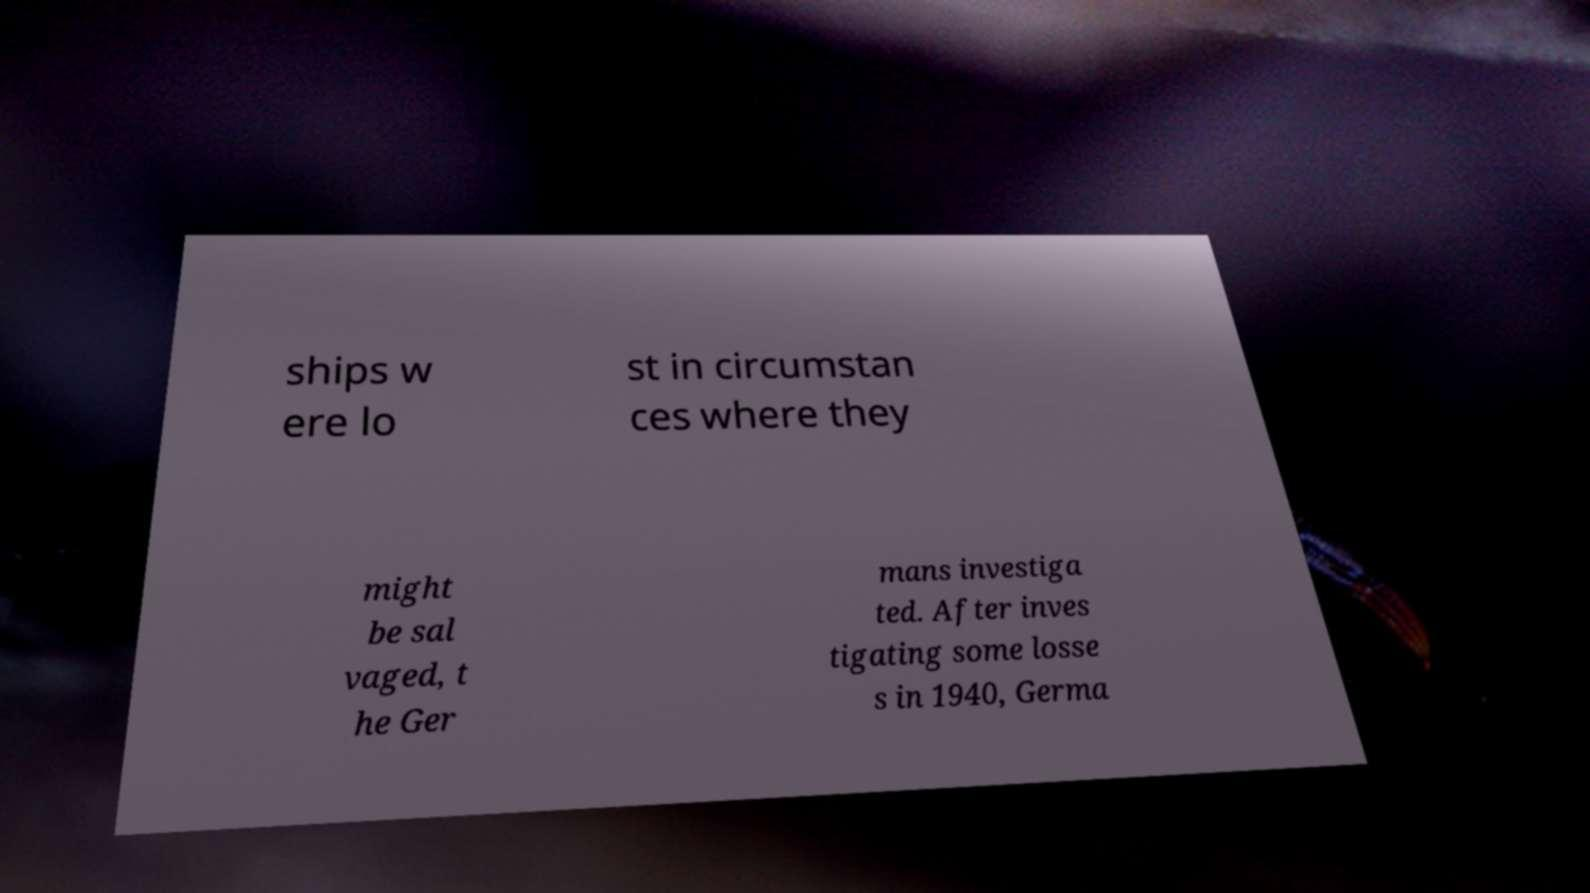Can you read and provide the text displayed in the image?This photo seems to have some interesting text. Can you extract and type it out for me? ships w ere lo st in circumstan ces where they might be sal vaged, t he Ger mans investiga ted. After inves tigating some losse s in 1940, Germa 